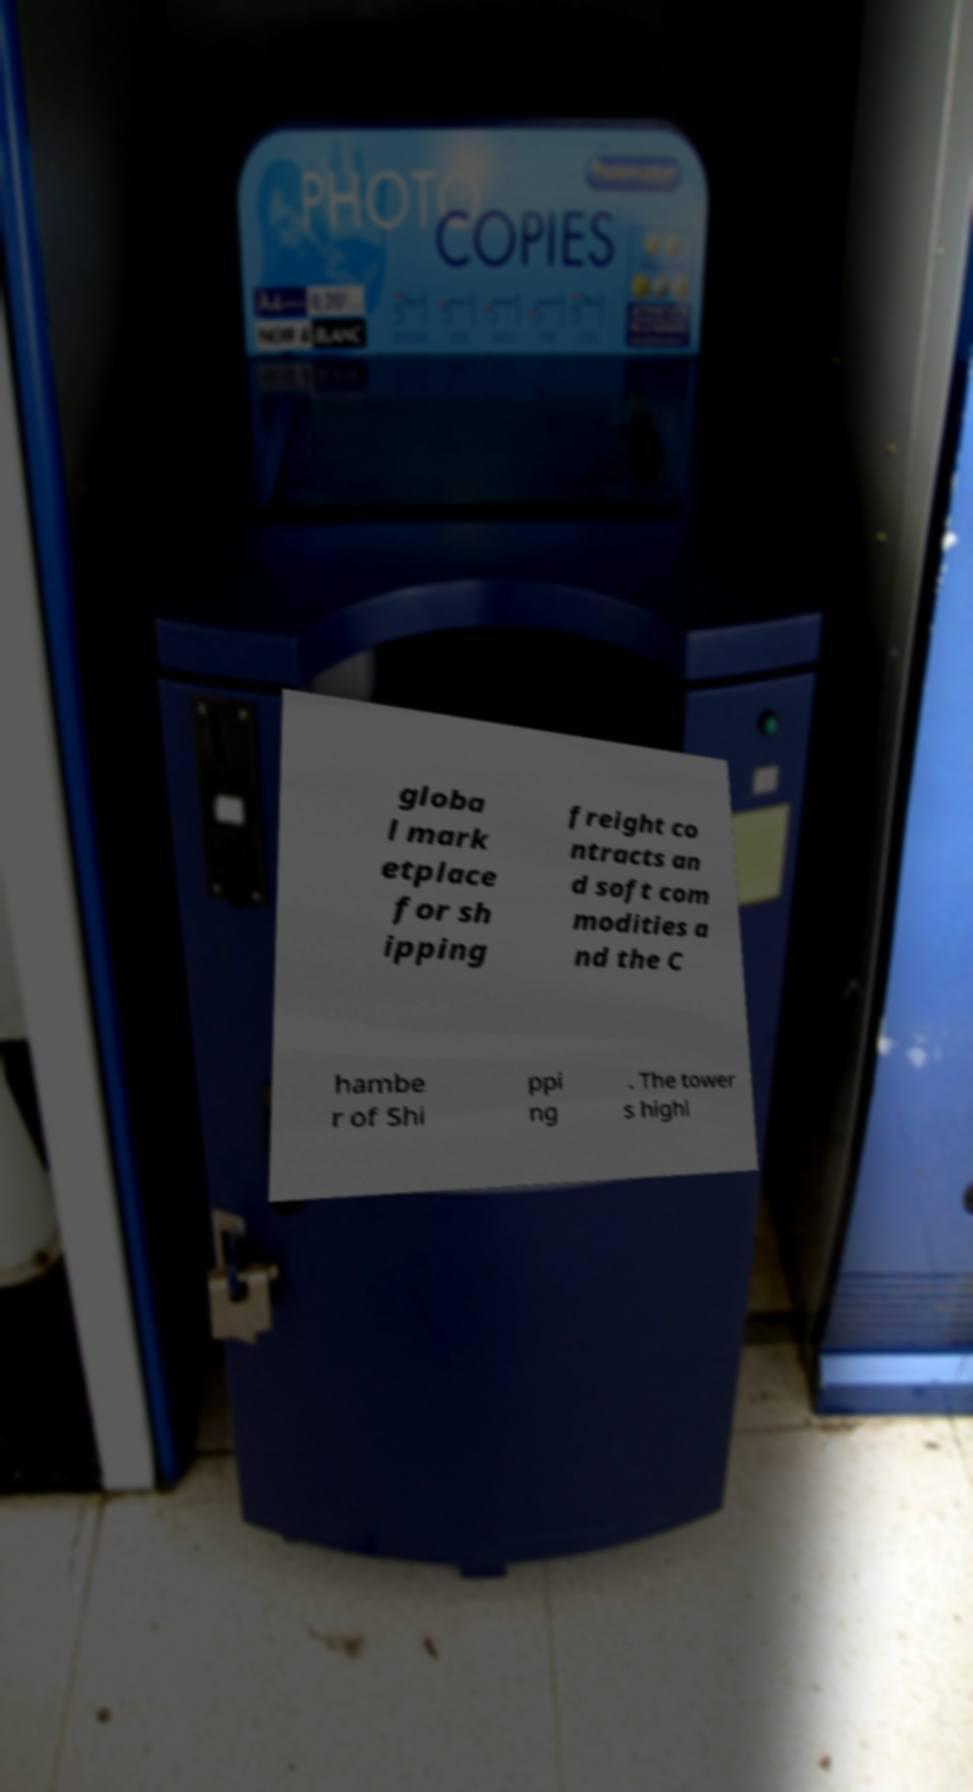For documentation purposes, I need the text within this image transcribed. Could you provide that? globa l mark etplace for sh ipping freight co ntracts an d soft com modities a nd the C hambe r of Shi ppi ng . The tower s highl 